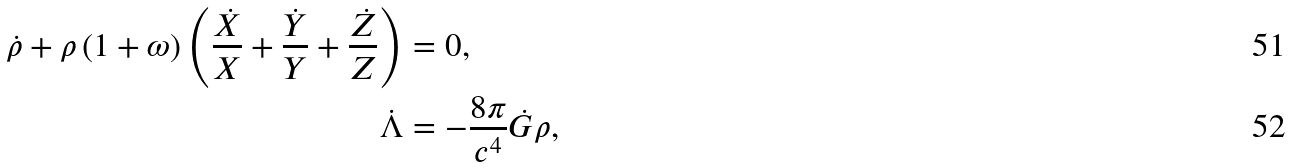Convert formula to latex. <formula><loc_0><loc_0><loc_500><loc_500>\dot { \rho } + \rho \left ( 1 + \omega \right ) \left ( \frac { \dot { X } } { X } + \frac { \dot { Y } } { Y } + \frac { \dot { Z } } { Z } \right ) & = 0 , \\ \dot { \Lambda } & = - \frac { 8 \pi } { c ^ { 4 } } \dot { G } \rho ,</formula> 